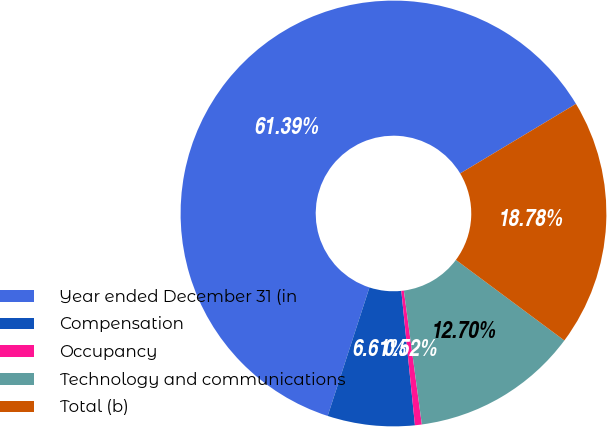<chart> <loc_0><loc_0><loc_500><loc_500><pie_chart><fcel>Year ended December 31 (in<fcel>Compensation<fcel>Occupancy<fcel>Technology and communications<fcel>Total (b)<nl><fcel>61.39%<fcel>6.61%<fcel>0.52%<fcel>12.7%<fcel>18.78%<nl></chart> 